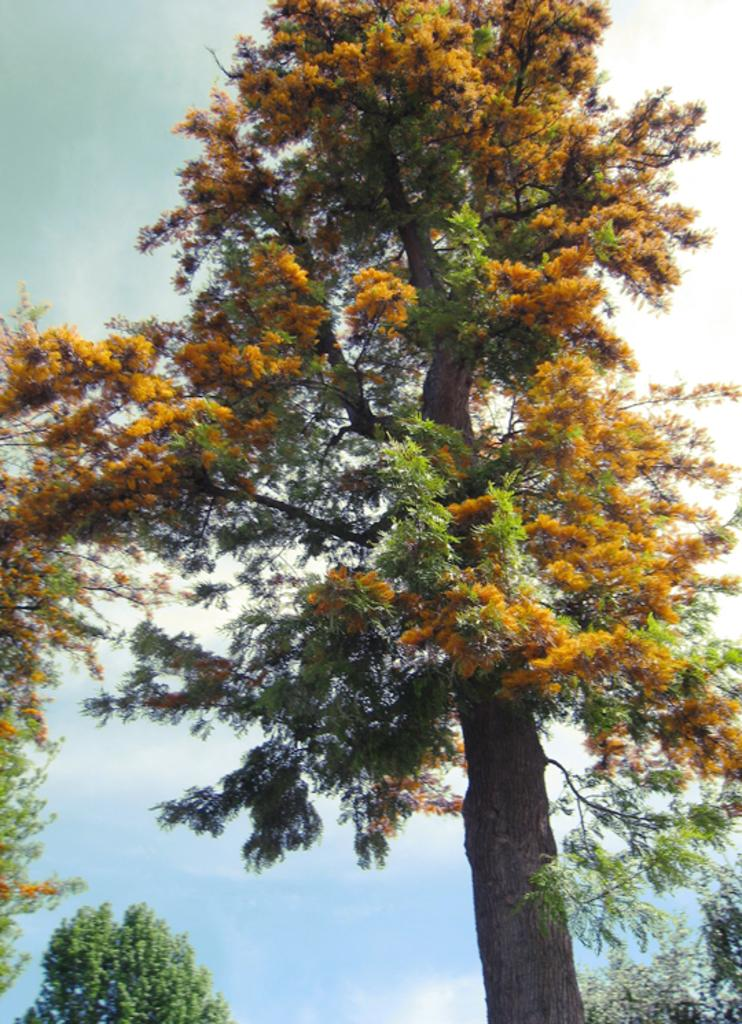What is the main object in the image? There is a tree in the image. What color is the background of the image? The background of the image is blue. Can you describe any specific features of the tree? There is a branch on the left side of the image. How many houses are visible in the image? There are no houses visible in the image; it features a tree with a branch on the left side. What type of support can be seen on the tree in the image? There is no visible support on the tree in the image; it is a standalone tree with a branch on the left side. 